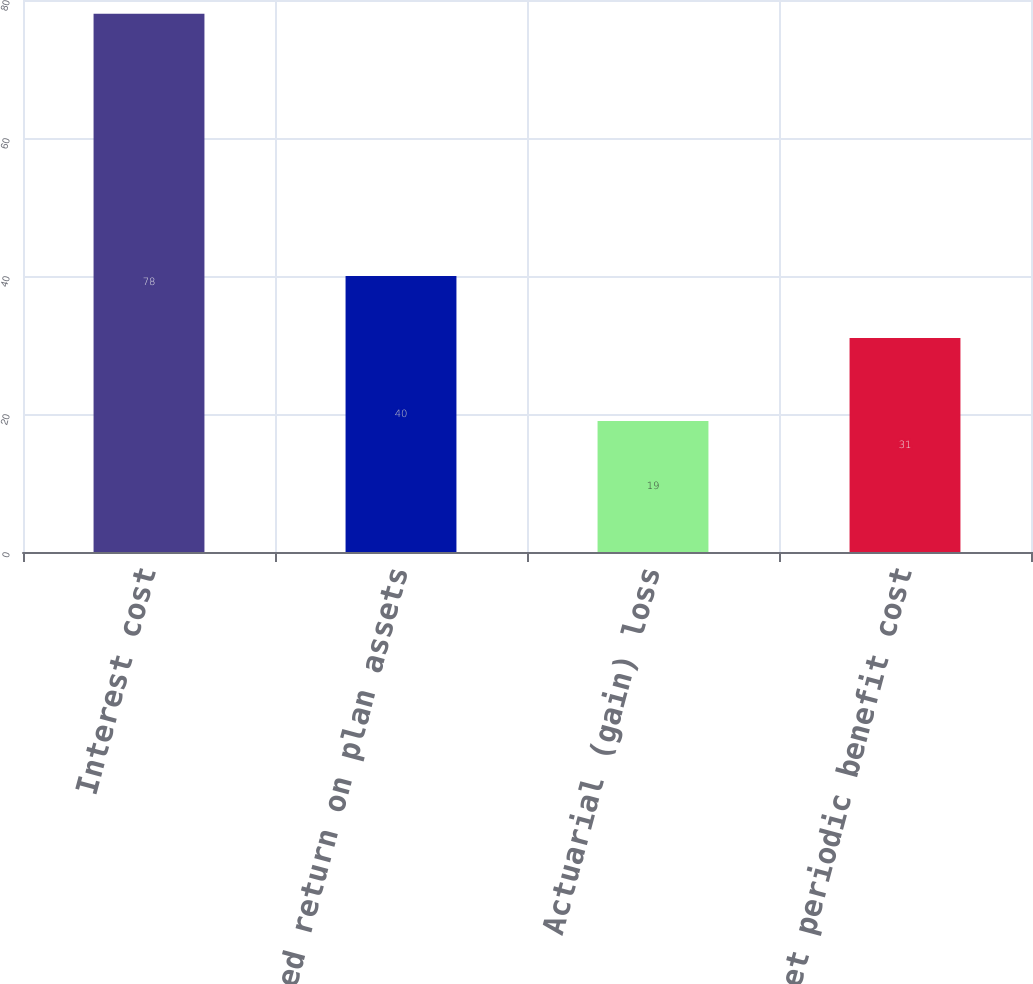<chart> <loc_0><loc_0><loc_500><loc_500><bar_chart><fcel>Interest cost<fcel>Expected return on plan assets<fcel>Actuarial (gain) loss<fcel>Net periodic benefit cost<nl><fcel>78<fcel>40<fcel>19<fcel>31<nl></chart> 